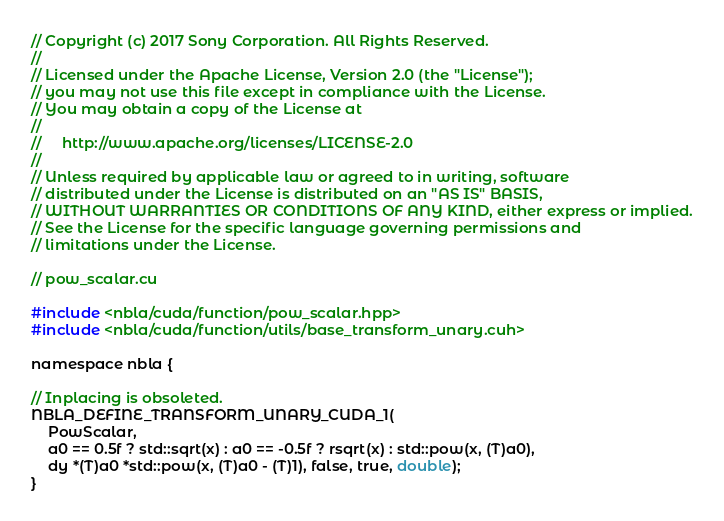<code> <loc_0><loc_0><loc_500><loc_500><_Cuda_>// Copyright (c) 2017 Sony Corporation. All Rights Reserved.
//
// Licensed under the Apache License, Version 2.0 (the "License");
// you may not use this file except in compliance with the License.
// You may obtain a copy of the License at
//
//     http://www.apache.org/licenses/LICENSE-2.0
//
// Unless required by applicable law or agreed to in writing, software
// distributed under the License is distributed on an "AS IS" BASIS,
// WITHOUT WARRANTIES OR CONDITIONS OF ANY KIND, either express or implied.
// See the License for the specific language governing permissions and
// limitations under the License.

// pow_scalar.cu

#include <nbla/cuda/function/pow_scalar.hpp>
#include <nbla/cuda/function/utils/base_transform_unary.cuh>

namespace nbla {

// Inplacing is obsoleted.
NBLA_DEFINE_TRANSFORM_UNARY_CUDA_1(
    PowScalar,
    a0 == 0.5f ? std::sqrt(x) : a0 == -0.5f ? rsqrt(x) : std::pow(x, (T)a0),
    dy *(T)a0 *std::pow(x, (T)a0 - (T)1), false, true, double);
}
</code> 